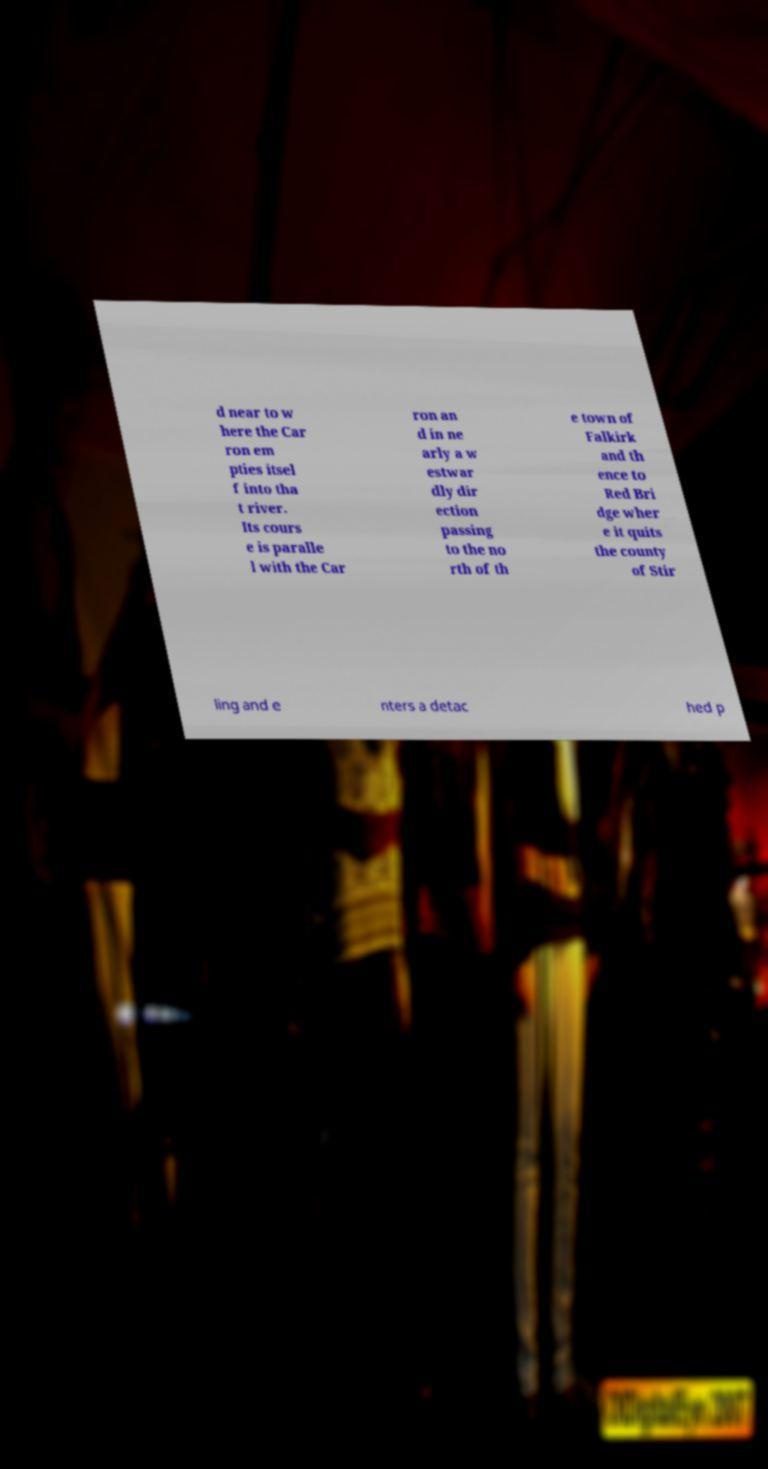Please read and relay the text visible in this image. What does it say? d near to w here the Car ron em pties itsel f into tha t river. Its cours e is paralle l with the Car ron an d in ne arly a w estwar dly dir ection passing to the no rth of th e town of Falkirk and th ence to Red Bri dge wher e it quits the county of Stir ling and e nters a detac hed p 